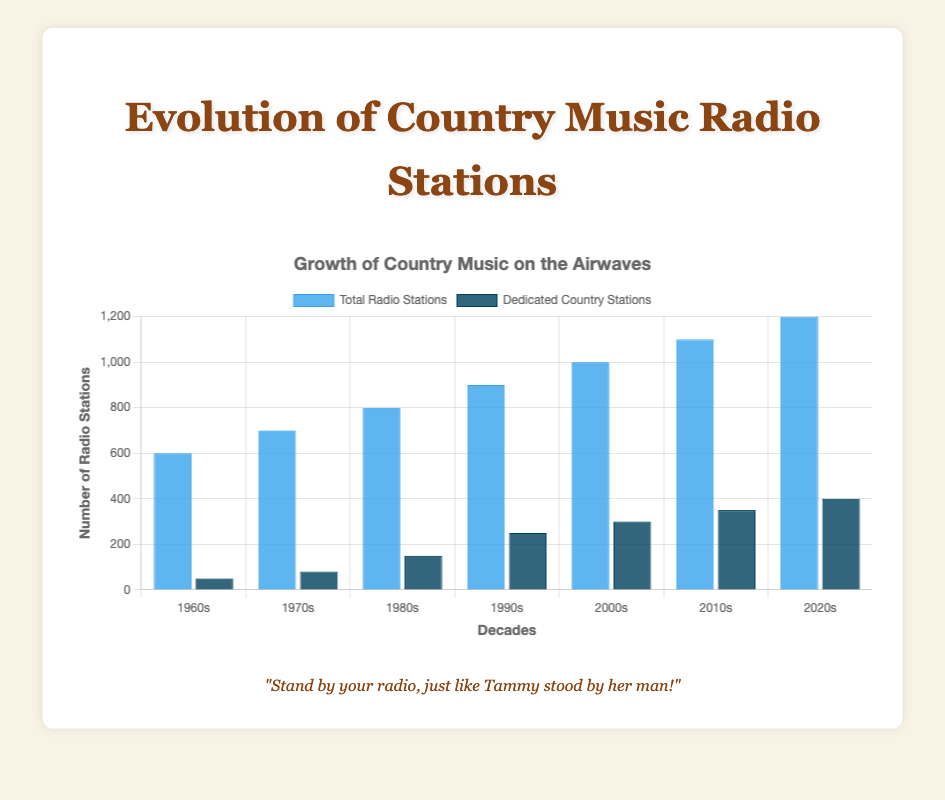What is the total number of radio stations in the 1980s? According to the bar labeled '1980s', the height of the blue bar representing total radio stations is 800.
Answer: 800 How many dedicated country stations were there in the 2020s? The dark blue bar for the 2020s shows the number 400, indicating dedicated country stations for that decade.
Answer: 400 By how much did the number of dedicated country stations increase from the 1970s to the 2000s? First, note the values for dedicated country stations in the 1970s (80) and 2000s (300). Calculate the increase by subtracting 80 from 300.
Answer: 220 Which decade had the largest increase in the number of dedicated country stations compared to the previous decade? Compare the increments for each decade: 1960s=50, 1970s=80-50=30, 1980s=150-80=70, 1990s=250-150=100, 2000s=300-250=50, 2010s=350-300=50, 2020s=400-350=50. The largest increase is from 1990s to 1980s with 100 stations.
Answer: 1990s What is the difference in the number of total radio stations between the 1960s and the 2020s? Subtract the total radio stations in the 1960s (600) from the total radio stations in the 2020s (1200).
Answer: 600 In which decade did the number of dedicated country stations first exceed 200? Looking at the dark blue bars, the 1990s bar is the first to exceed 200, with a value of 250.
Answer: 1990s What can be said about the trend of dedicated country stations over the decades? Observe the dark blue bars increasing gradually from the 1960s to the 2020s, indicating a consistent rise in the number of dedicated country stations.
Answer: Increasing trend How does the number of dedicated country stations in the 2010s compare to the 1980s? The dark blue bar shows that in the 2010s there were 350 stations, while in the 1980s there were 150 stations. 350 is greater than 150 by 200 stations.
Answer: 350 > 150 What is the ratio of dedicated country stations to total radio stations in the 2000s? Divide the number of dedicated country stations in the 2000s (300) by the total radio stations in the same decade (1000): 300/1000 = 0.3.
Answer: 0.3 